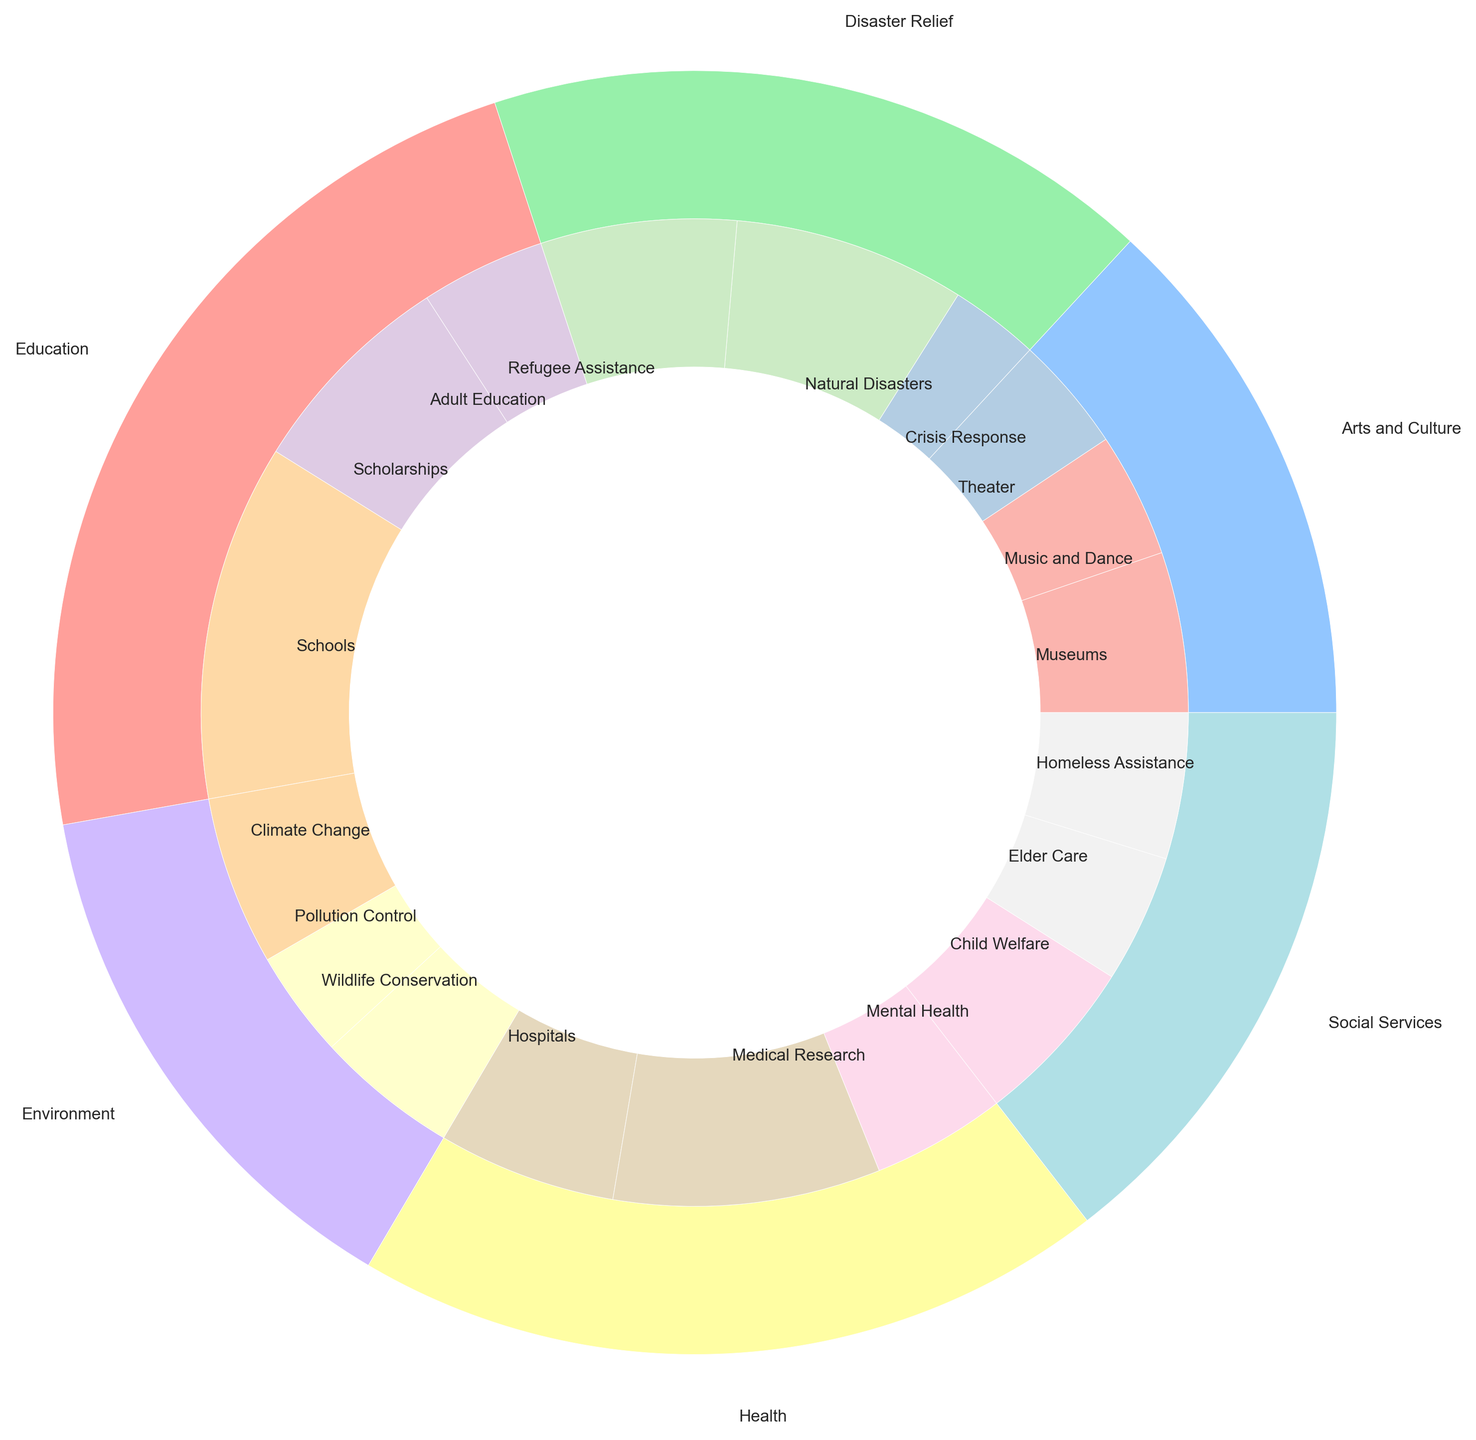Which category received the highest total amount of donations? To determine this, you need to look at the outer labels and sizes of the pie chart. The category with the largest section represents the highest total amount.
Answer: Education How much more is donated to Health than to Social Services? First, find the total donations for Health and Social Services from the chart. Health has $325,000 and Social Services has $249,000. The difference is $325,000 - $249,000.
Answer: $76,000 What percentage of the total donations is given to Disaster Relief for Natural Disasters? To determine this, find the segment representing Natural Disasters under Disaster Relief. It has $130,000. The total donations can be calculated by summing all the amounts ($1,380,000). The percentage is ($130,000 / $1,380,000) * 100.
Answer: 9.42% Is the amount donated to Theater more or less than the amount donated to Mental Health? Compare the sizes of the segments labeled Theater and Mental Health in the inner pie chart. Theater received $65,000 whereas Mental Health received $75,000.
Answer: Less Which segment in the inner pie has the second highest donation amount and which category does it belong to? First, identify the subcategories with the highest donations and sort them. The second highest subcategory is Schools under Education with $200,000.
Answer: Schools under Education How much total donation was given to Environment-related causes? Sum the donations for all subcategories within the Environment category. Wildlife Conservation: $80,000, Climate Change: $95,000, Pollution Control: $60,000. Total: $80,000 + $95,000 + $60,000.
Answer: $235,000 Among the health-related donations, which specific subcategory received the smallest share? Within the Health category, compare the sections of Medical Research, Hospitals, and Mental Health. Mental Health received the smallest share of $75,000.
Answer: Mental Health Which category has a larger total donation: Arts and Culture or Disaster Relief? Compare the total amounts for Arts and Culture ($225,000) and Disaster Relief ($290,000) using the outer pie chart.
Answer: Disaster Relief What is the difference in donation amounts between the largest Health subcategory and the smallest Education subcategory? Identify the subcategories for both categories. The largest Health subcategory is Medical Research ($150,000) and the smallest Education subcategory is Adult Education ($70,000). The difference is $150,000 - $70,000.
Answer: $80,000 